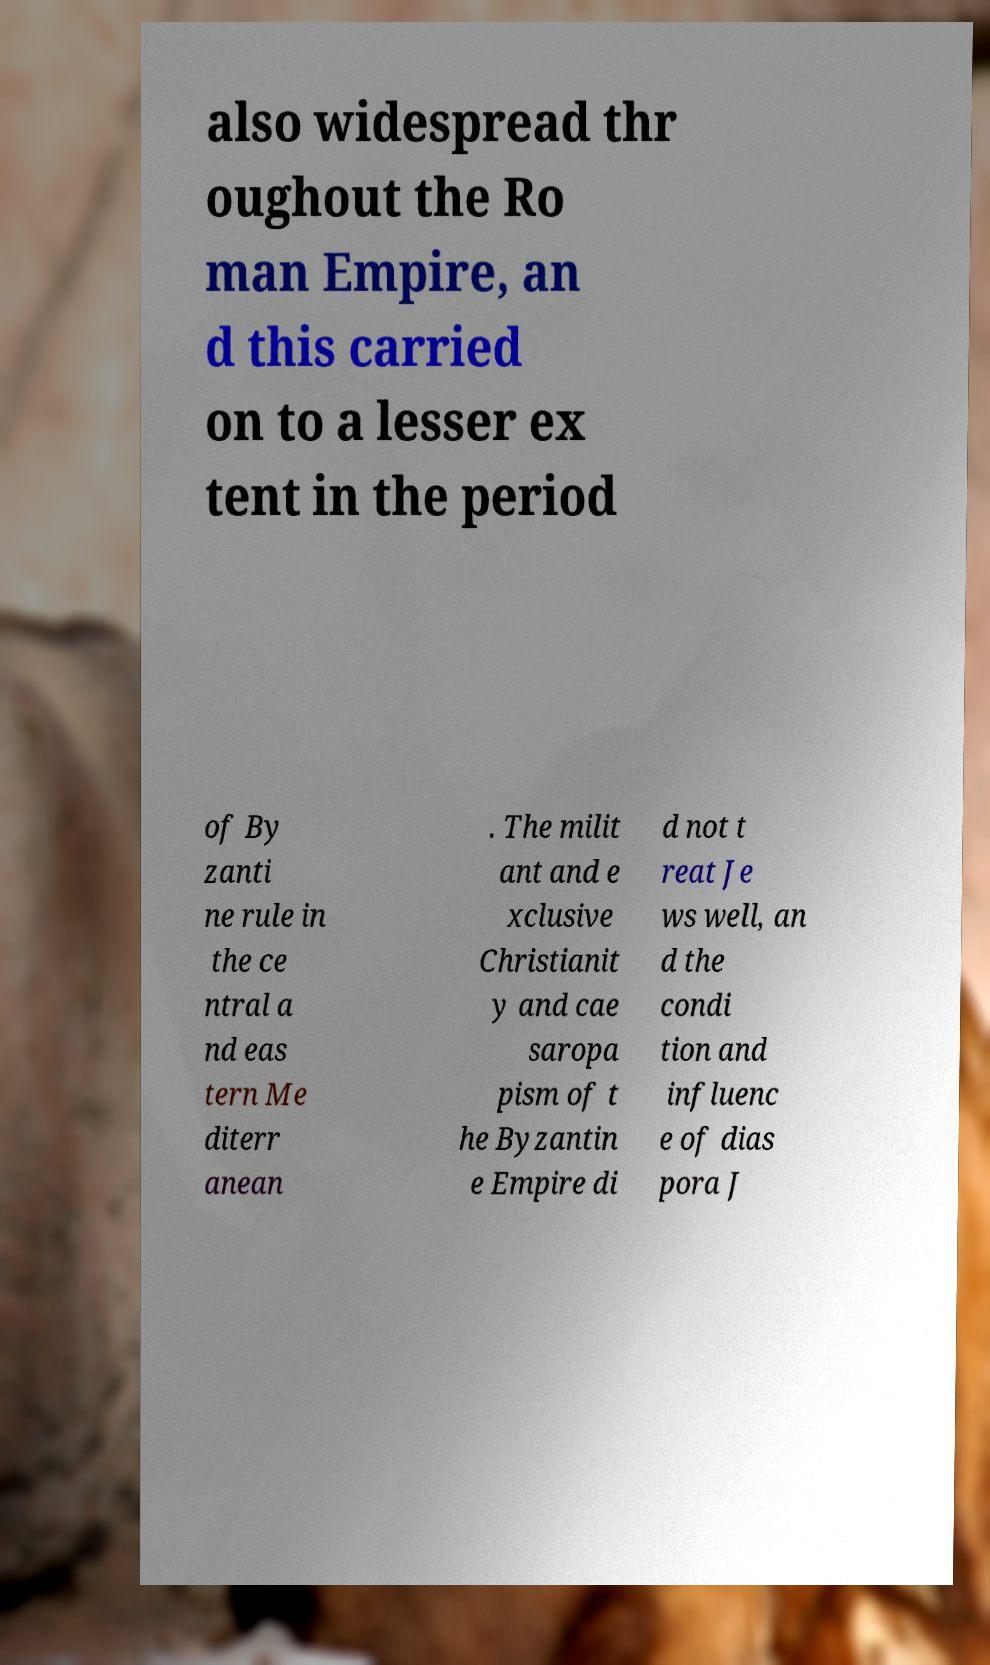I need the written content from this picture converted into text. Can you do that? also widespread thr oughout the Ro man Empire, an d this carried on to a lesser ex tent in the period of By zanti ne rule in the ce ntral a nd eas tern Me diterr anean . The milit ant and e xclusive Christianit y and cae saropa pism of t he Byzantin e Empire di d not t reat Je ws well, an d the condi tion and influenc e of dias pora J 